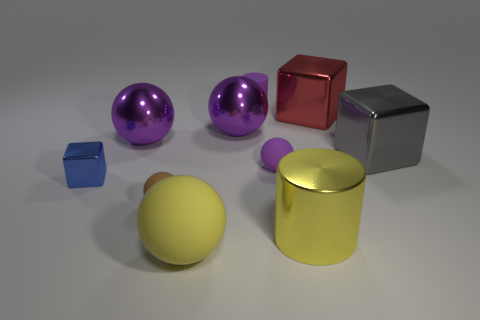Subtract all cyan cubes. How many purple balls are left? 3 Subtract all red balls. Subtract all red cylinders. How many balls are left? 5 Subtract all cylinders. How many objects are left? 8 Add 5 yellow matte objects. How many yellow matte objects exist? 6 Subtract 0 gray cylinders. How many objects are left? 10 Subtract all small blocks. Subtract all tiny brown matte spheres. How many objects are left? 8 Add 9 blue things. How many blue things are left? 10 